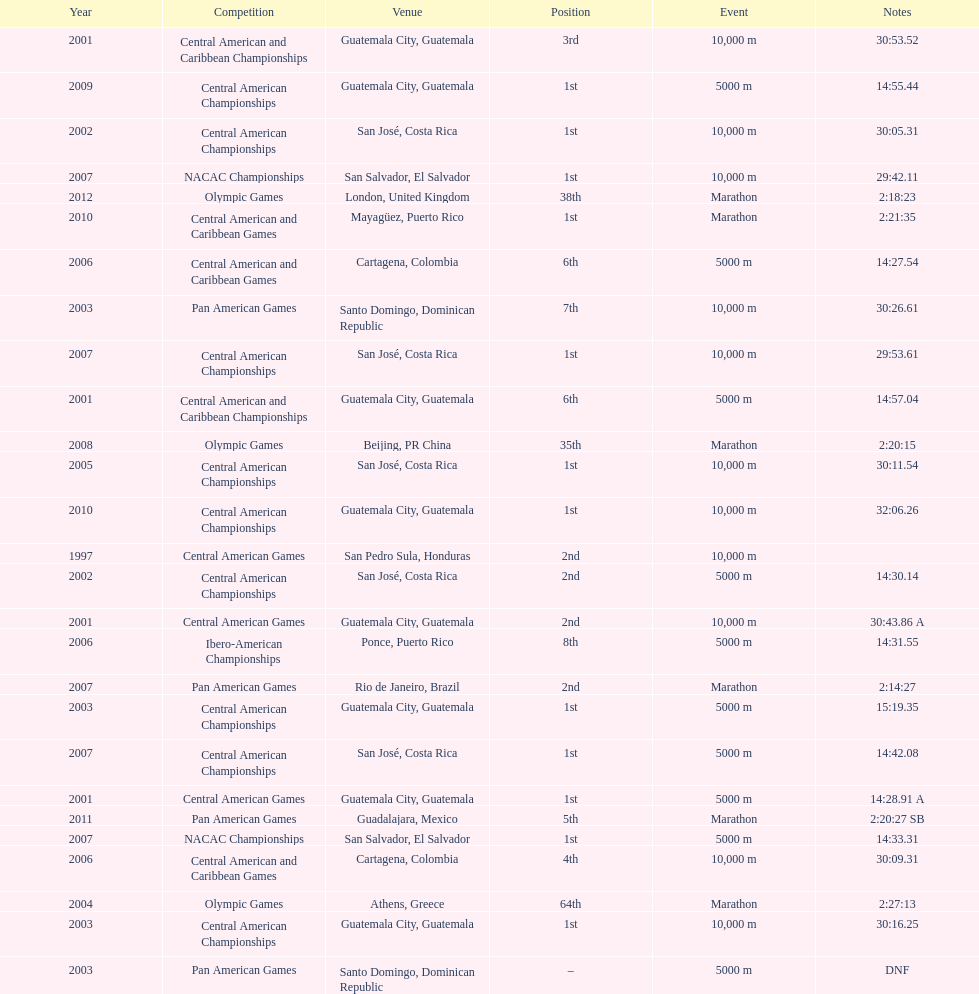Which race is cited more often between the 10,000m and the 5000m? 10,000 m. 